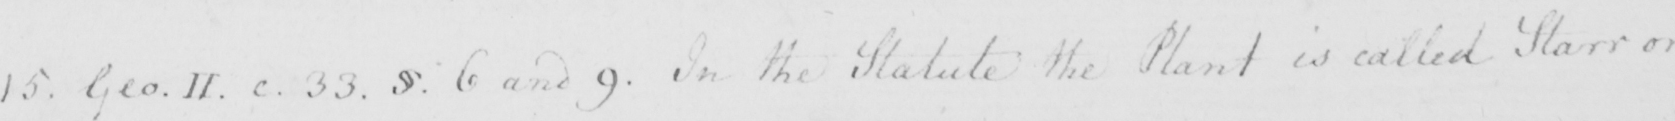Please provide the text content of this handwritten line. 15 . Geo . II . c . 33 . §  . 6 and 9 . In the Statute the Plant is called Starr or 